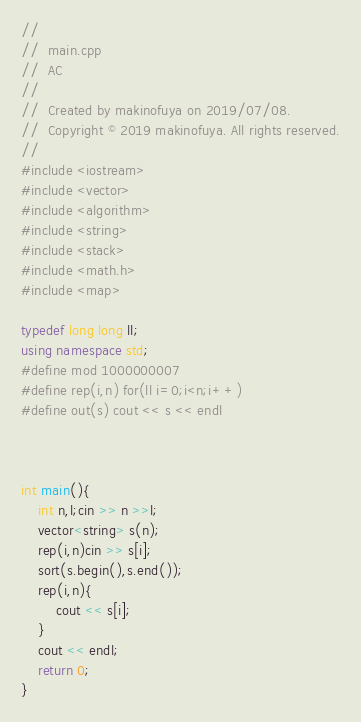Convert code to text. <code><loc_0><loc_0><loc_500><loc_500><_C++_>//
//  main.cpp
//  AC
//
//  Created by makinofuya on 2019/07/08.
//  Copyright © 2019 makinofuya. All rights reserved.
//
#include <iostream>
#include <vector>
#include <algorithm>
#include <string>
#include <stack>
#include <math.h>
#include <map>

typedef long long ll;
using namespace std;
#define mod 1000000007
#define rep(i,n) for(ll i=0;i<n;i++)
#define out(s) cout << s << endl



int main(){
    int n,l;cin >> n >>l;
    vector<string> s(n);
    rep(i,n)cin >> s[i];
    sort(s.begin(),s.end());
    rep(i,n){
        cout << s[i];
    }
    cout << endl;
    return 0;
}
</code> 